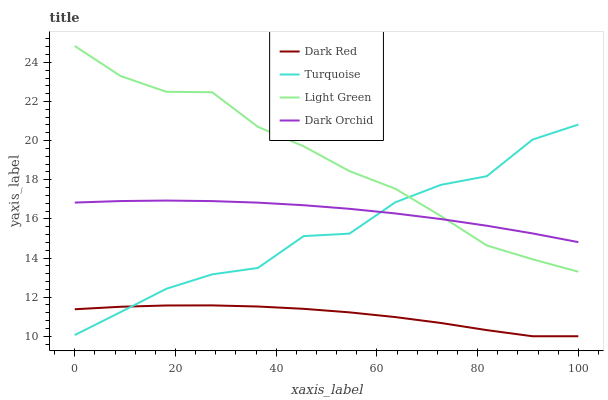Does Turquoise have the minimum area under the curve?
Answer yes or no. No. Does Turquoise have the maximum area under the curve?
Answer yes or no. No. Is Turquoise the smoothest?
Answer yes or no. No. Is Dark Orchid the roughest?
Answer yes or no. No. Does Turquoise have the lowest value?
Answer yes or no. No. Does Turquoise have the highest value?
Answer yes or no. No. Is Dark Red less than Light Green?
Answer yes or no. Yes. Is Light Green greater than Dark Red?
Answer yes or no. Yes. Does Dark Red intersect Light Green?
Answer yes or no. No. 